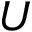<formula> <loc_0><loc_0><loc_500><loc_500>U</formula> 